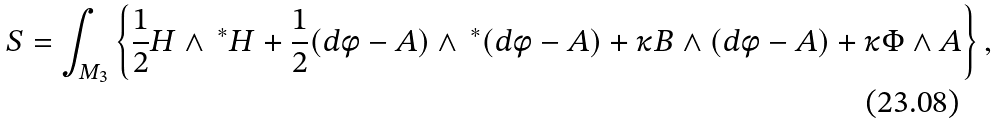<formula> <loc_0><loc_0><loc_500><loc_500>S = \int _ { M _ { 3 } } \left \{ \frac { 1 } { 2 } H \wedge \, ^ { * } H + \frac { 1 } { 2 } ( d \phi - A ) \wedge \, ^ { * } ( d \phi - A ) + \kappa B \wedge ( d \phi - A ) + \kappa \Phi \wedge A \right \} ,</formula> 